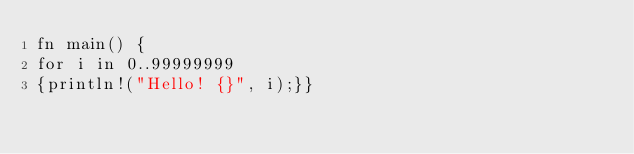<code> <loc_0><loc_0><loc_500><loc_500><_Rust_>fn main() {
for i in 0..99999999
{println!("Hello! {}", i);}}
</code> 